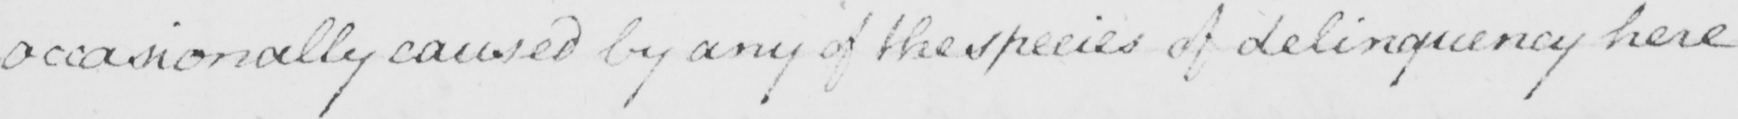Transcribe the text shown in this historical manuscript line. occasionally caused by any of the species of delinquency here 